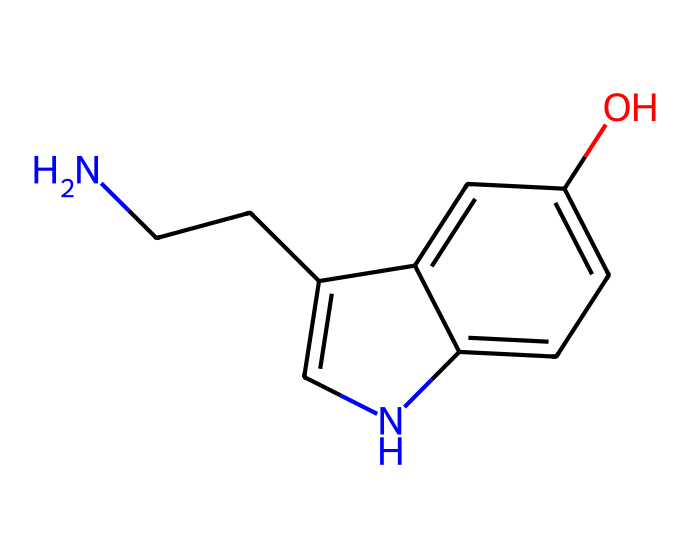What is the name of this chemical? The provided SMILES representation corresponds to the molecular structure of serotonin, a neurotransmitter.
Answer: serotonin How many carbon atoms are there in this structure? By analyzing the SMILES notation, we can count the carbon atoms (C). There are 10 carbon atoms present in the structure.
Answer: 10 What functional group is present in this chemical? The hydroxyl (-OH) group is indicated in the structure by the presence of 'O', which denotes its function as a phenolic compound.
Answer: hydroxyl How many nitrogen atoms are in serotonin? Observing the SMILES structure, the nitrogen atom (N) appears only once, indicating there is one nitrogen atom in serotonin.
Answer: 1 What effect does this chemical have on mood? Serotonin is well-known for its role in mood regulation, commonly referred to as the "feel-good" neurotransmitter, which impacts mood positively.
Answer: mood regulation Which part of this chemical is responsible for its neurotransmitter function? The indole ring system, which incorporates both the nitrogen atom and the characteristic structure of serotonin contributing to its binding and functioning as a neurotransmitter, is key here.
Answer: indole ring system 